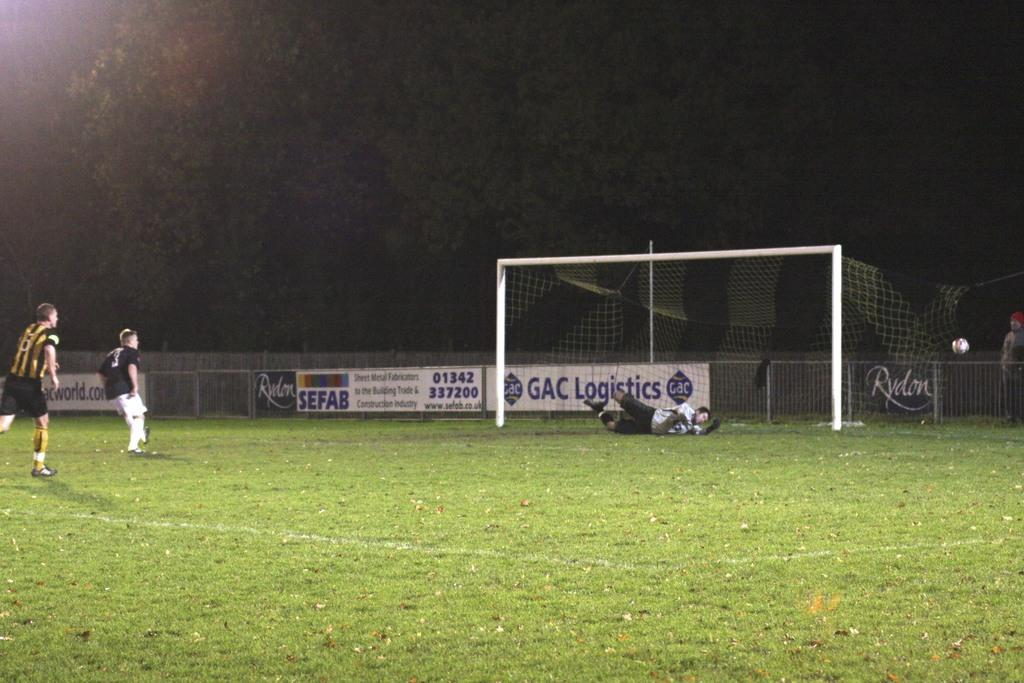<image>
Describe the image concisely. A soccer field with a Sefab banner on the fence in the background. 